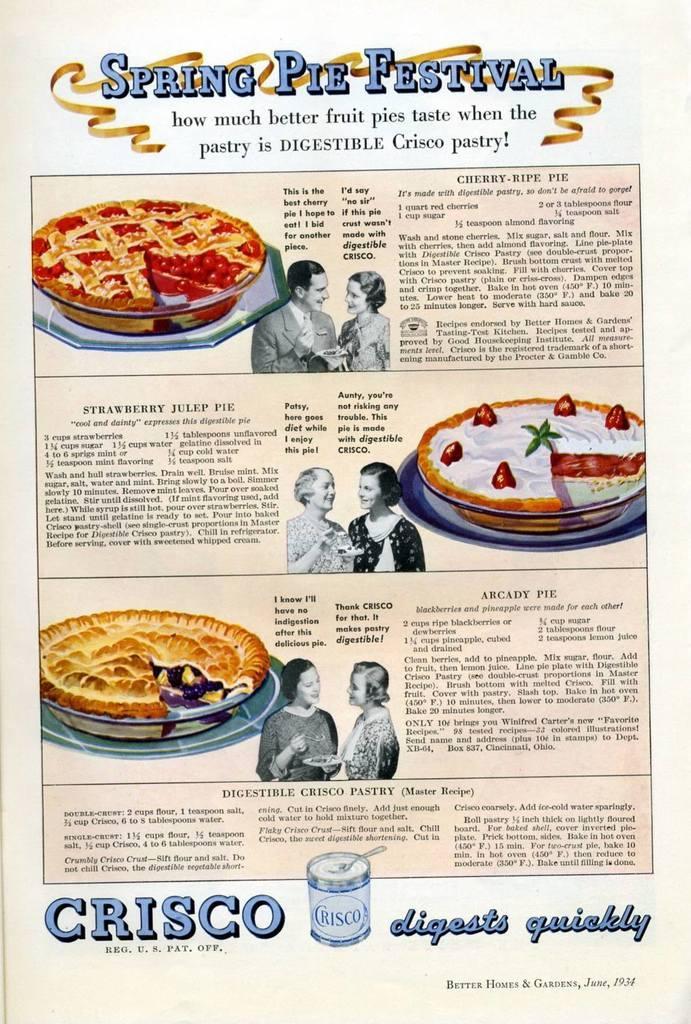Can you describe this image briefly? In this picture I can see a poster with some text and I can see pictures of a human and some food items. 